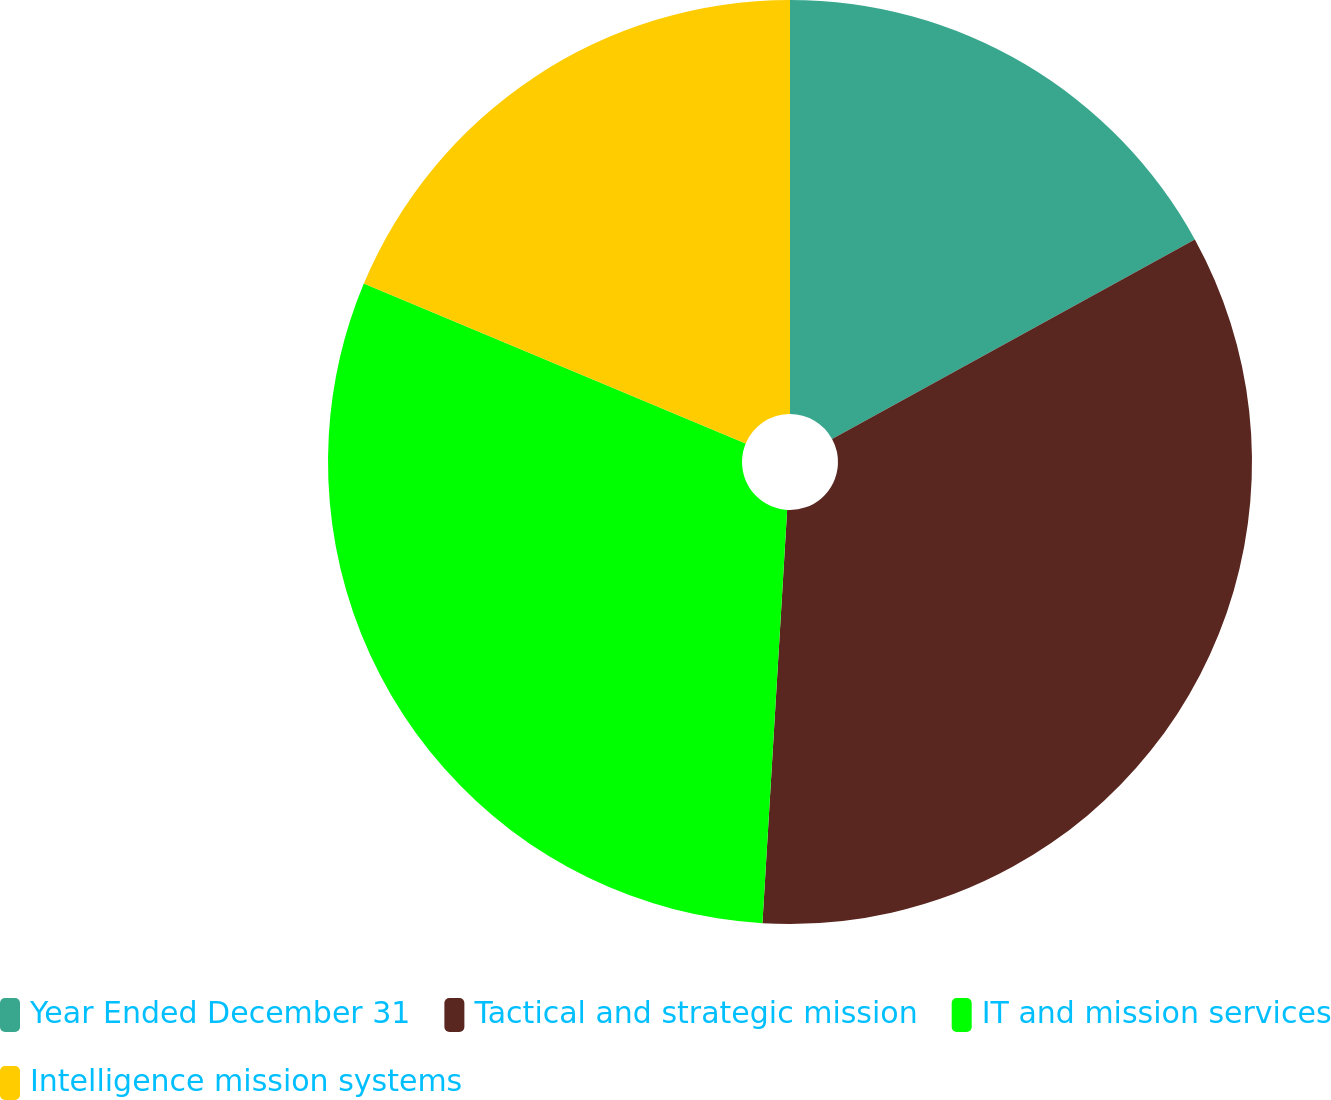<chart> <loc_0><loc_0><loc_500><loc_500><pie_chart><fcel>Year Ended December 31<fcel>Tactical and strategic mission<fcel>IT and mission services<fcel>Intelligence mission systems<nl><fcel>17.0%<fcel>33.95%<fcel>30.36%<fcel>18.69%<nl></chart> 